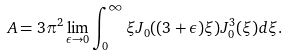<formula> <loc_0><loc_0><loc_500><loc_500>A = 3 \pi ^ { 2 } \lim _ { \epsilon \rightarrow 0 } \int _ { 0 } ^ { \infty } \xi J _ { 0 } ( ( 3 + \epsilon ) \xi ) J _ { 0 } ^ { 3 } ( \xi ) d \xi .</formula> 